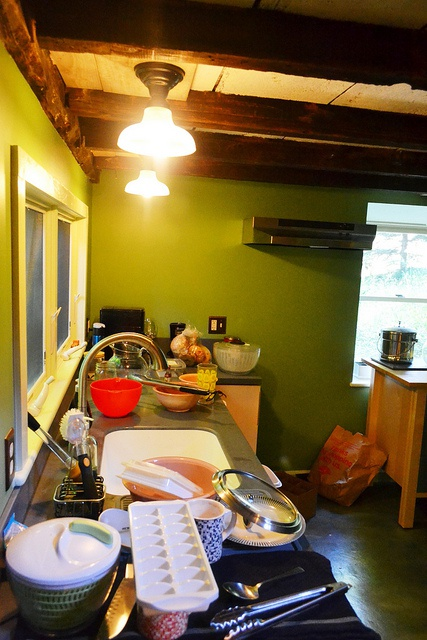Describe the objects in this image and their specific colors. I can see bowl in maroon, lavender, black, and gray tones, dining table in maroon and white tones, sink in maroon, khaki, lightgray, and tan tones, bowl in maroon, red, brown, and olive tones, and cup in maroon, darkgray, lightgray, blue, and tan tones in this image. 